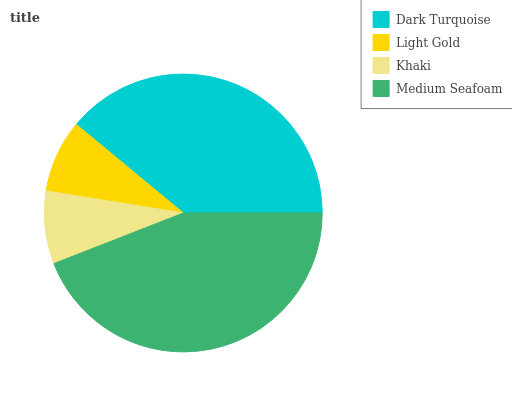Is Khaki the minimum?
Answer yes or no. Yes. Is Medium Seafoam the maximum?
Answer yes or no. Yes. Is Light Gold the minimum?
Answer yes or no. No. Is Light Gold the maximum?
Answer yes or no. No. Is Dark Turquoise greater than Light Gold?
Answer yes or no. Yes. Is Light Gold less than Dark Turquoise?
Answer yes or no. Yes. Is Light Gold greater than Dark Turquoise?
Answer yes or no. No. Is Dark Turquoise less than Light Gold?
Answer yes or no. No. Is Dark Turquoise the high median?
Answer yes or no. Yes. Is Light Gold the low median?
Answer yes or no. Yes. Is Medium Seafoam the high median?
Answer yes or no. No. Is Khaki the low median?
Answer yes or no. No. 